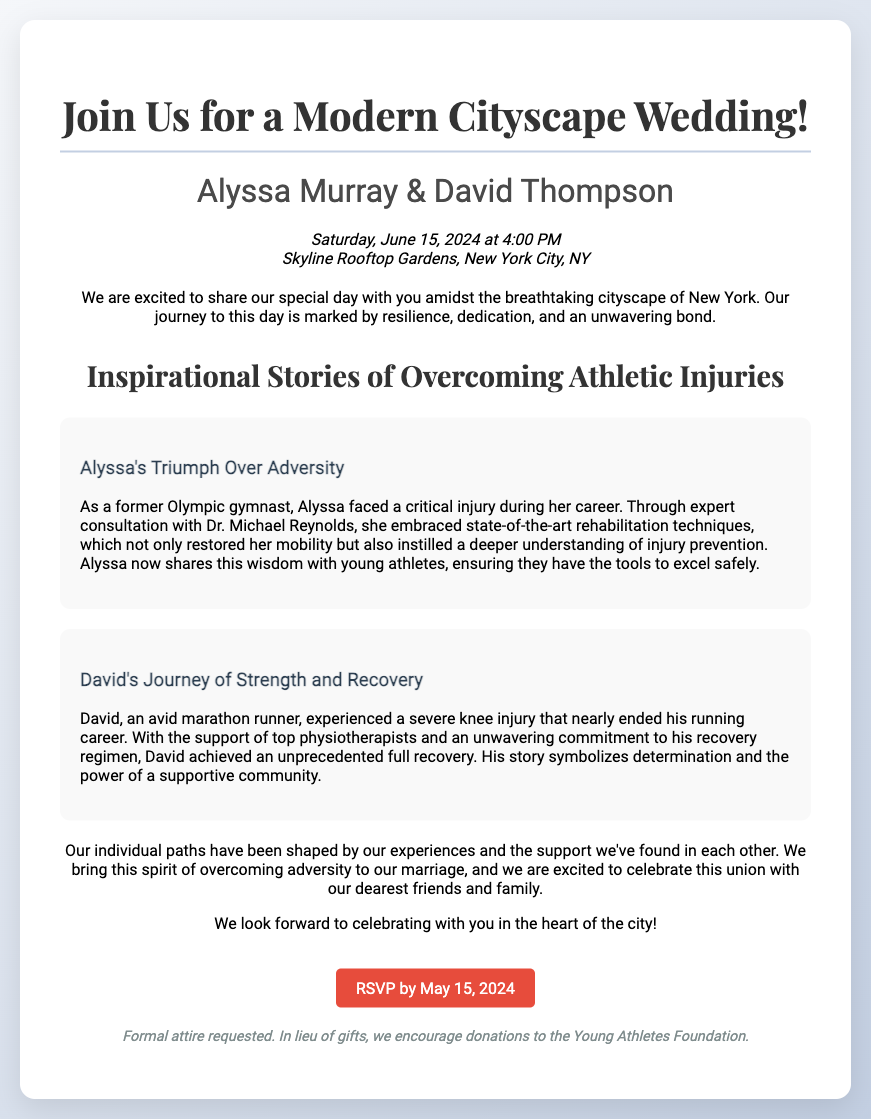What date is the wedding? The wedding is scheduled for Saturday, June 15, 2024.
Answer: June 15, 2024 Where is the wedding taking place? The wedding will be held at Skyline Rooftop Gardens, New York City, NY.
Answer: Skyline Rooftop Gardens, New York City, NY Who are the couple getting married? Alyssa Murray and David Thompson are the couple featured in the invitation.
Answer: Alyssa Murray & David Thompson What time does the wedding start? The wedding ceremony is set to begin at 4:00 PM.
Answer: 4:00 PM What is a key theme of the wedding invitation? The invitation highlights the theme of inspirational stories of overcoming athletic injuries.
Answer: Inspirational Stories of Overcoming Athletic Injuries What kind of attire is requested for the wedding? The invitation mentions that formal attire is requested.
Answer: Formal attire What significant medical professional is mentioned in the document? The document refers to Dr. Michael Reynolds as an important figure in Alyssa's recovery.
Answer: Dr. Michael Reynolds What is encouraged in lieu of gifts? The couple encourages donations to the Young Athletes Foundation instead of gifts.
Answer: Donations to the Young Athletes Foundation What is the RSVP deadline? The RSVP by date specified in the invitation is May 15, 2024.
Answer: May 15, 2024 